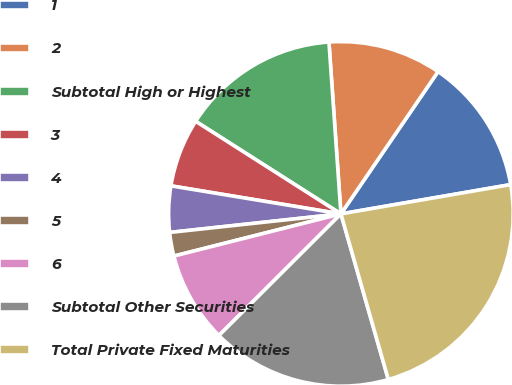Convert chart. <chart><loc_0><loc_0><loc_500><loc_500><pie_chart><fcel>1<fcel>2<fcel>Subtotal High or Highest<fcel>3<fcel>4<fcel>5<fcel>6<fcel>Subtotal Other Securities<fcel>Total Private Fixed Maturities<nl><fcel>12.75%<fcel>10.64%<fcel>14.86%<fcel>6.43%<fcel>4.32%<fcel>2.22%<fcel>8.54%<fcel>16.96%<fcel>23.28%<nl></chart> 